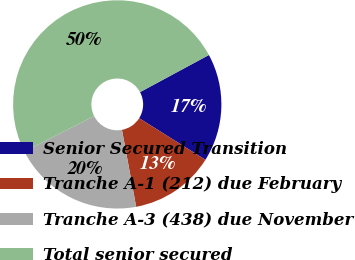Convert chart to OTSL. <chart><loc_0><loc_0><loc_500><loc_500><pie_chart><fcel>Senior Secured Transition<fcel>Tranche A-1 (212) due February<fcel>Tranche A-3 (438) due November<fcel>Total senior secured<nl><fcel>16.8%<fcel>13.16%<fcel>20.44%<fcel>49.6%<nl></chart> 